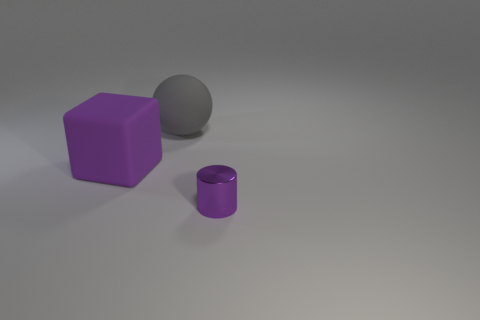Add 2 large objects. How many objects exist? 5 Subtract all cylinders. How many objects are left? 2 Subtract all small blue metallic cubes. Subtract all tiny purple objects. How many objects are left? 2 Add 1 purple rubber objects. How many purple rubber objects are left? 2 Add 3 large purple matte things. How many large purple matte things exist? 4 Subtract 0 green spheres. How many objects are left? 3 